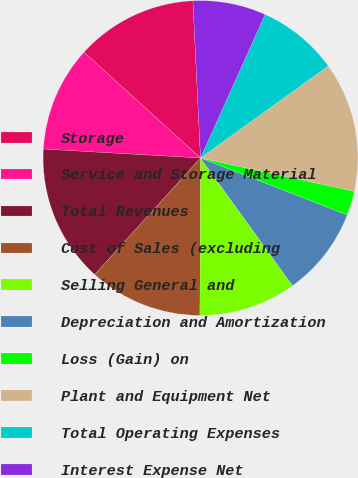Convert chart. <chart><loc_0><loc_0><loc_500><loc_500><pie_chart><fcel>Storage<fcel>Service and Storage Material<fcel>Total Revenues<fcel>Cost of Sales (excluding<fcel>Selling General and<fcel>Depreciation and Amortization<fcel>Loss (Gain) on<fcel>Plant and Equipment Net<fcel>Total Operating Expenses<fcel>Interest Expense Net<nl><fcel>12.5%<fcel>10.83%<fcel>14.17%<fcel>11.67%<fcel>10.0%<fcel>9.17%<fcel>2.5%<fcel>13.33%<fcel>8.33%<fcel>7.5%<nl></chart> 